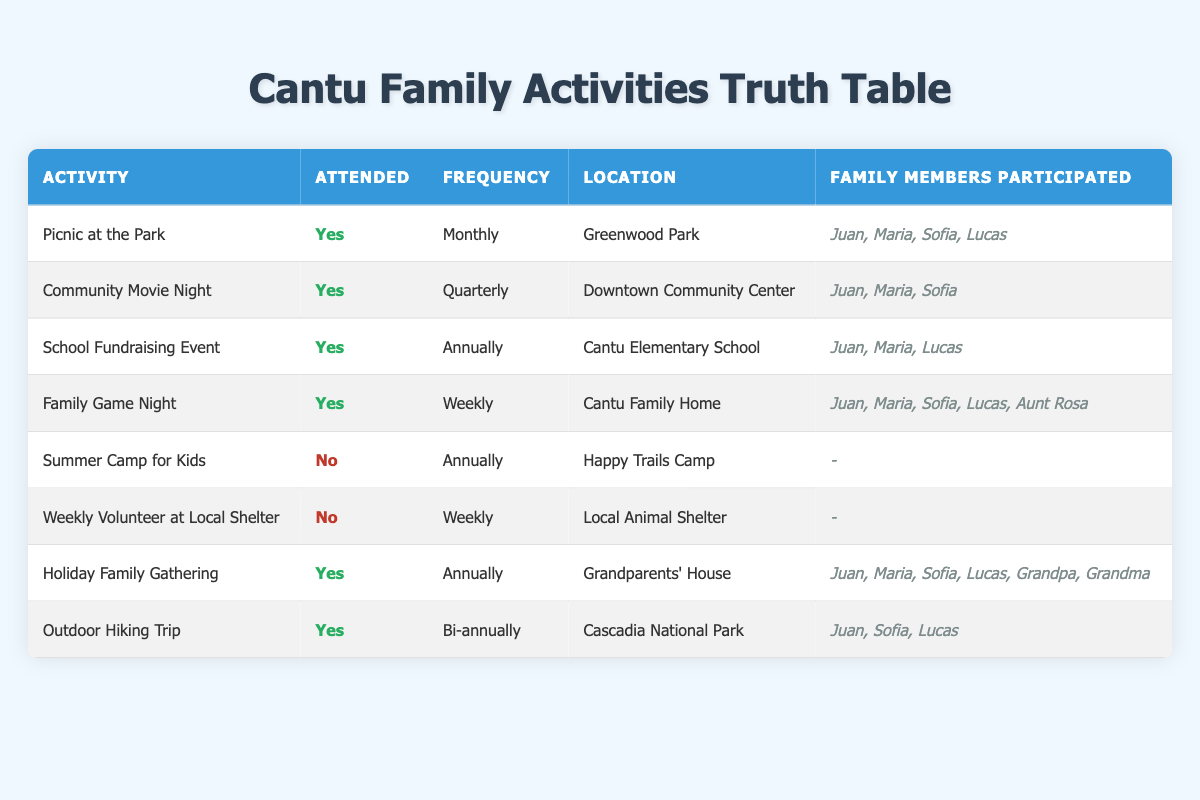What activities did the Cantu family attend monthly? According to the table, the "Picnic at the Park" is the only activity listed with a frequency of "Monthly" that the Cantu family attended.
Answer: Picnic at the Park How many family members participated in the Family Game Night? In the table, the row for "Family Game Night" shows that five family members participated: Juan Cantu, Maria Cantu, Sofia Cantu, Lucas Cantu, and Aunt Rosa.
Answer: 5 Did the Cantu family attend a picnic at the park? The table indicates that the "Picnic at the Park" was attended by the Cantu family, marked as "Yes."
Answer: Yes What is the frequency of the Outdoor Hiking Trip? From the table, the "Outdoor Hiking Trip" has a frequency of "Bi-annually." This means it occurs twice a year.
Answer: Bi-annually Which activities did the Cantu family not attend? The table shows two activities that the Cantu family did not attend: "Summer Camp for Kids" and "Weekly Volunteer at Local Shelter," both marked as "No" under the "Attended" column.
Answer: Summer Camp for Kids, Weekly Volunteer at Local Shelter How many activities did the Cantu family attend in total? By counting the "Attended" activities marked as "Yes" in the table, we find that there are five attending activities: Picnic at the Park, Community Movie Night, School Fundraising Event, Family Game Night, Holiday Family Gathering, and Outdoor Hiking Trip. Thus, the total is 6 attended activities.
Answer: 6 At which location did the Cantu family attend the Holiday Family Gathering? The table specifies that the "Holiday Family Gathering" took place at the "Grandparents' House."
Answer: Grandparents' House Which activity was attended by the least number of participants? Looking at the table, the "Community Movie Night" was attended by only three family members: Juan Cantu, Maria Cantu, and Sofia Cantu, compared to other activities with more participants.
Answer: Community Movie Night 